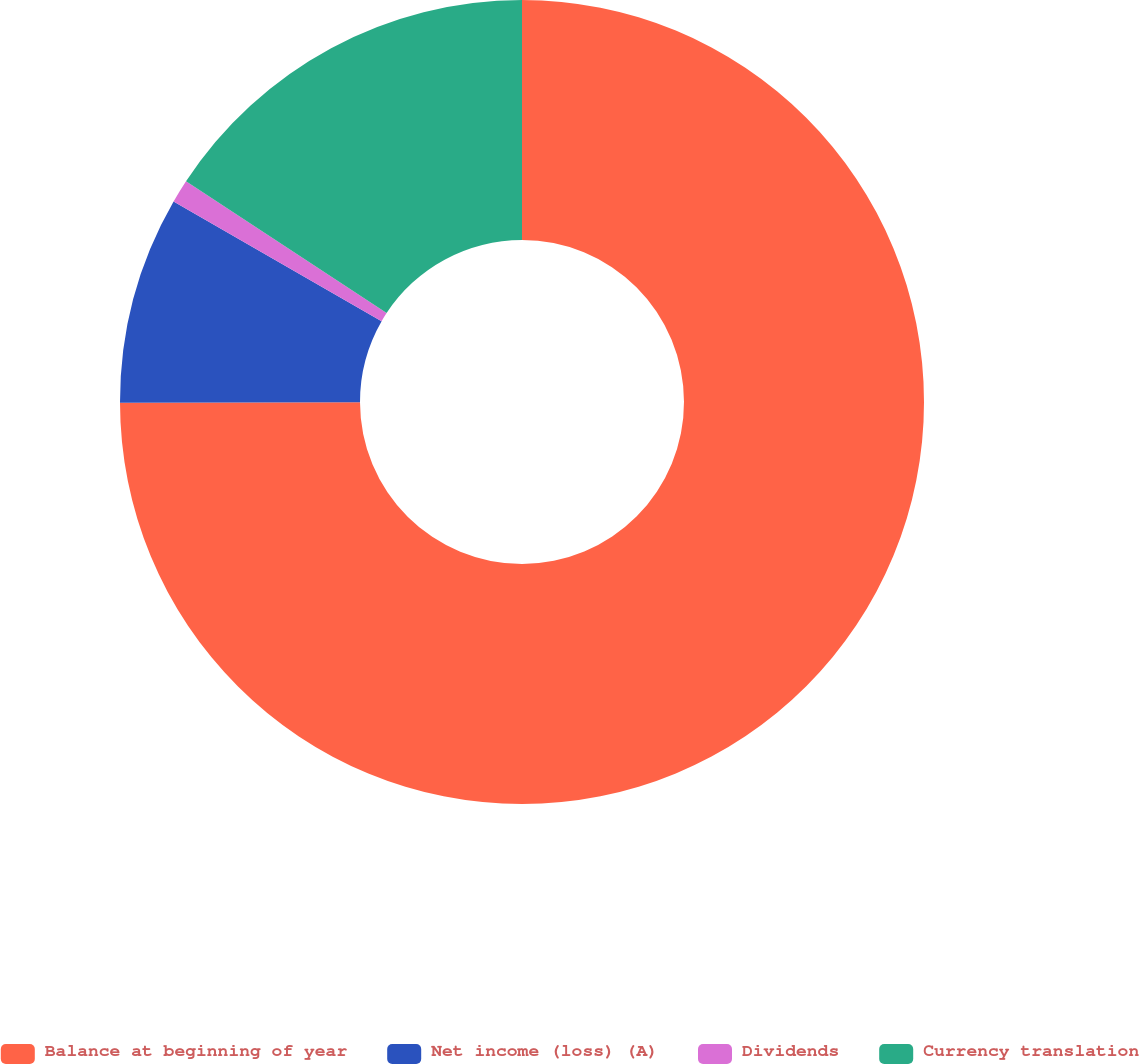Convert chart. <chart><loc_0><loc_0><loc_500><loc_500><pie_chart><fcel>Balance at beginning of year<fcel>Net income (loss) (A)<fcel>Dividends<fcel>Currency translation<nl><fcel>74.98%<fcel>8.34%<fcel>0.94%<fcel>15.75%<nl></chart> 